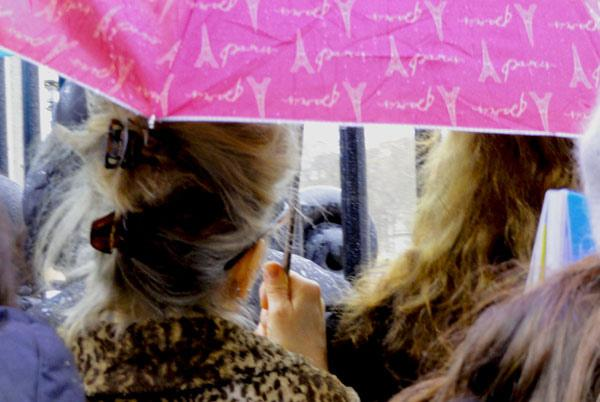What do the clips on the woman's head do for her?

Choices:
A) apply makeup
B) tie bread
C) relive headaches
D) hold hair hold hair 